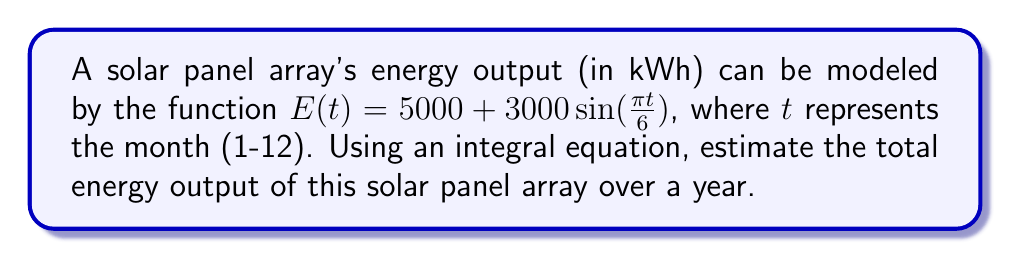What is the answer to this math problem? To estimate the total energy output over a year, we need to integrate the function $E(t)$ from $t=0$ to $t=12$. The integral equation is:

$$\text{Total Energy} = \int_{0}^{12} E(t) dt = \int_{0}^{12} [5000 + 3000\sin(\frac{\pi t}{6})] dt$$

Let's solve this integral step by step:

1) Separate the integral:
   $$\int_{0}^{12} 5000 dt + \int_{0}^{12} 3000\sin(\frac{\pi t}{6}) dt$$

2) Solve the first part:
   $$5000t\big|_{0}^{12} = 5000 \cdot 12 - 5000 \cdot 0 = 60000$$

3) For the second part, use the substitution $u = \frac{\pi t}{6}$:
   $$3000 \cdot \frac{6}{\pi} \int_{0}^{2\pi} \sin(u) du$$

4) Solve this integral:
   $$3000 \cdot \frac{6}{\pi} [-\cos(u)]\big|_{0}^{2\pi} = 3000 \cdot \frac{6}{\pi} [(-\cos(2\pi)) - (-\cos(0))] = 0$$

5) Sum the results:
   $$60000 + 0 = 60000$$

Therefore, the total energy output over a year is estimated to be 60,000 kWh.
Answer: 60,000 kWh 